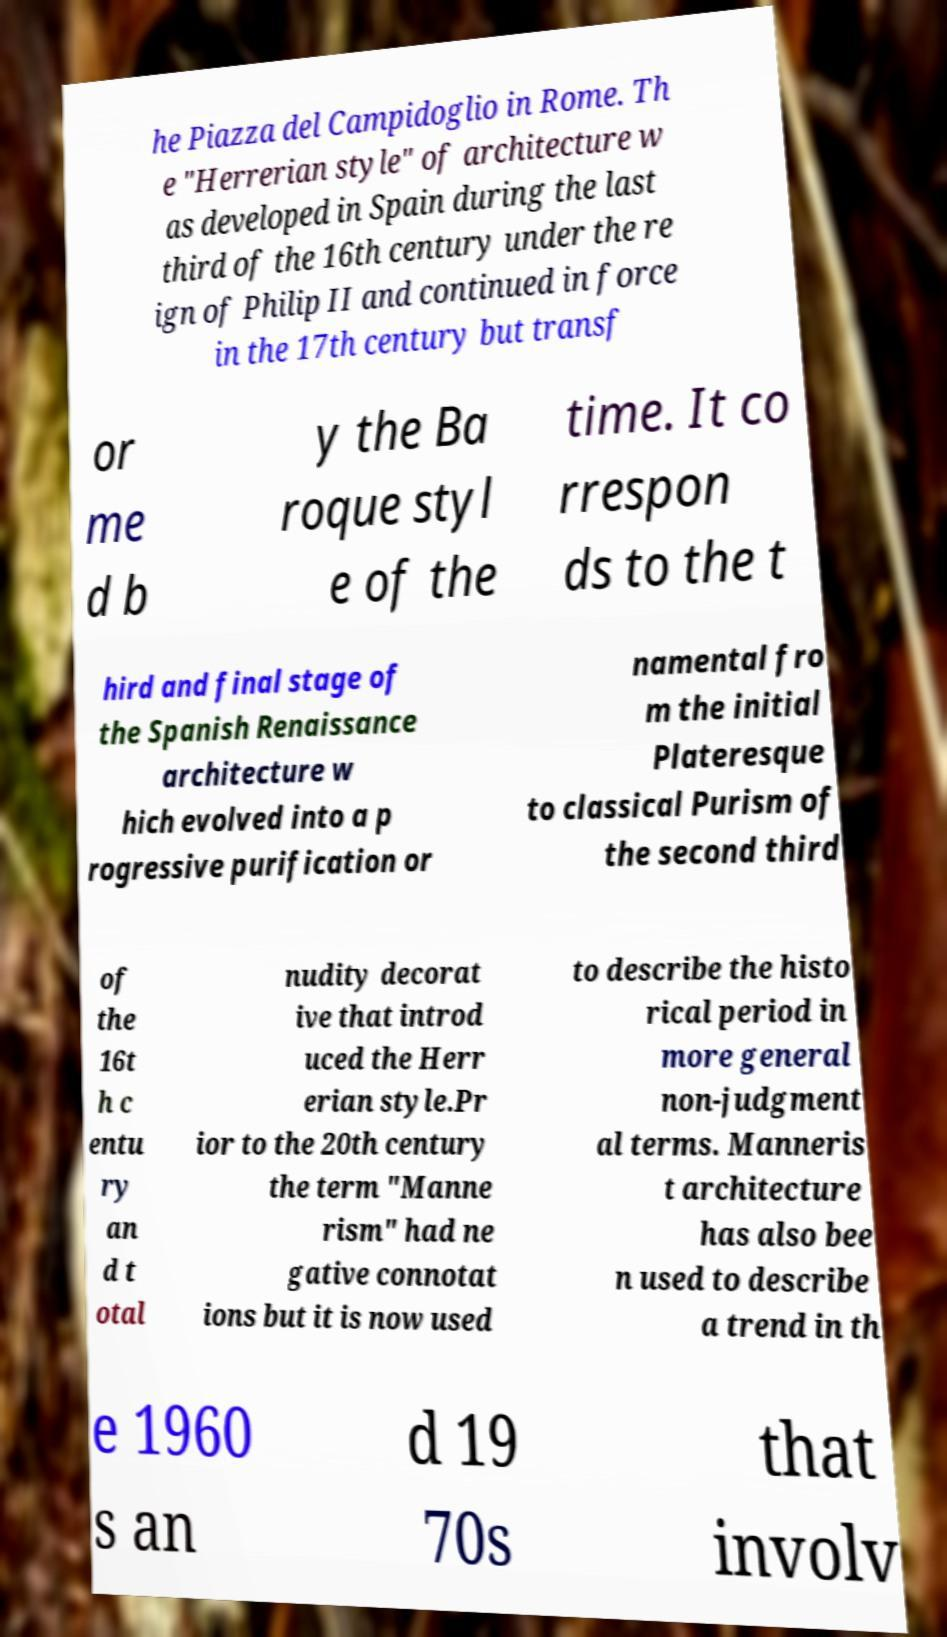Can you accurately transcribe the text from the provided image for me? he Piazza del Campidoglio in Rome. Th e "Herrerian style" of architecture w as developed in Spain during the last third of the 16th century under the re ign of Philip II and continued in force in the 17th century but transf or me d b y the Ba roque styl e of the time. It co rrespon ds to the t hird and final stage of the Spanish Renaissance architecture w hich evolved into a p rogressive purification or namental fro m the initial Plateresque to classical Purism of the second third of the 16t h c entu ry an d t otal nudity decorat ive that introd uced the Herr erian style.Pr ior to the 20th century the term "Manne rism" had ne gative connotat ions but it is now used to describe the histo rical period in more general non-judgment al terms. Manneris t architecture has also bee n used to describe a trend in th e 1960 s an d 19 70s that involv 